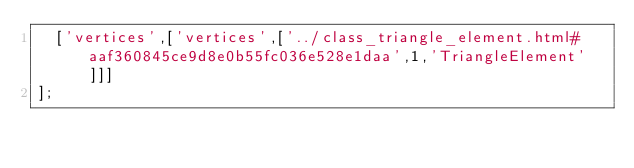Convert code to text. <code><loc_0><loc_0><loc_500><loc_500><_JavaScript_>  ['vertices',['vertices',['../class_triangle_element.html#aaf360845ce9d8e0b55fc036e528e1daa',1,'TriangleElement']]]
];
</code> 